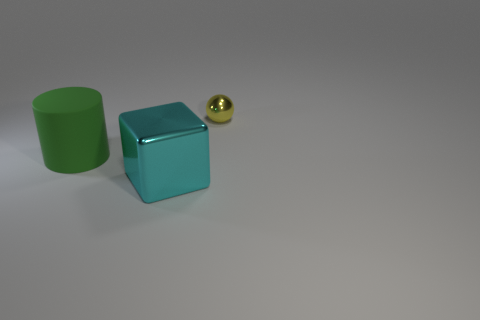Add 3 big green things. How many objects exist? 6 Subtract all balls. How many objects are left? 2 Subtract 0 brown balls. How many objects are left? 3 Subtract all large cylinders. Subtract all large green rubber cylinders. How many objects are left? 1 Add 1 green objects. How many green objects are left? 2 Add 1 yellow objects. How many yellow objects exist? 2 